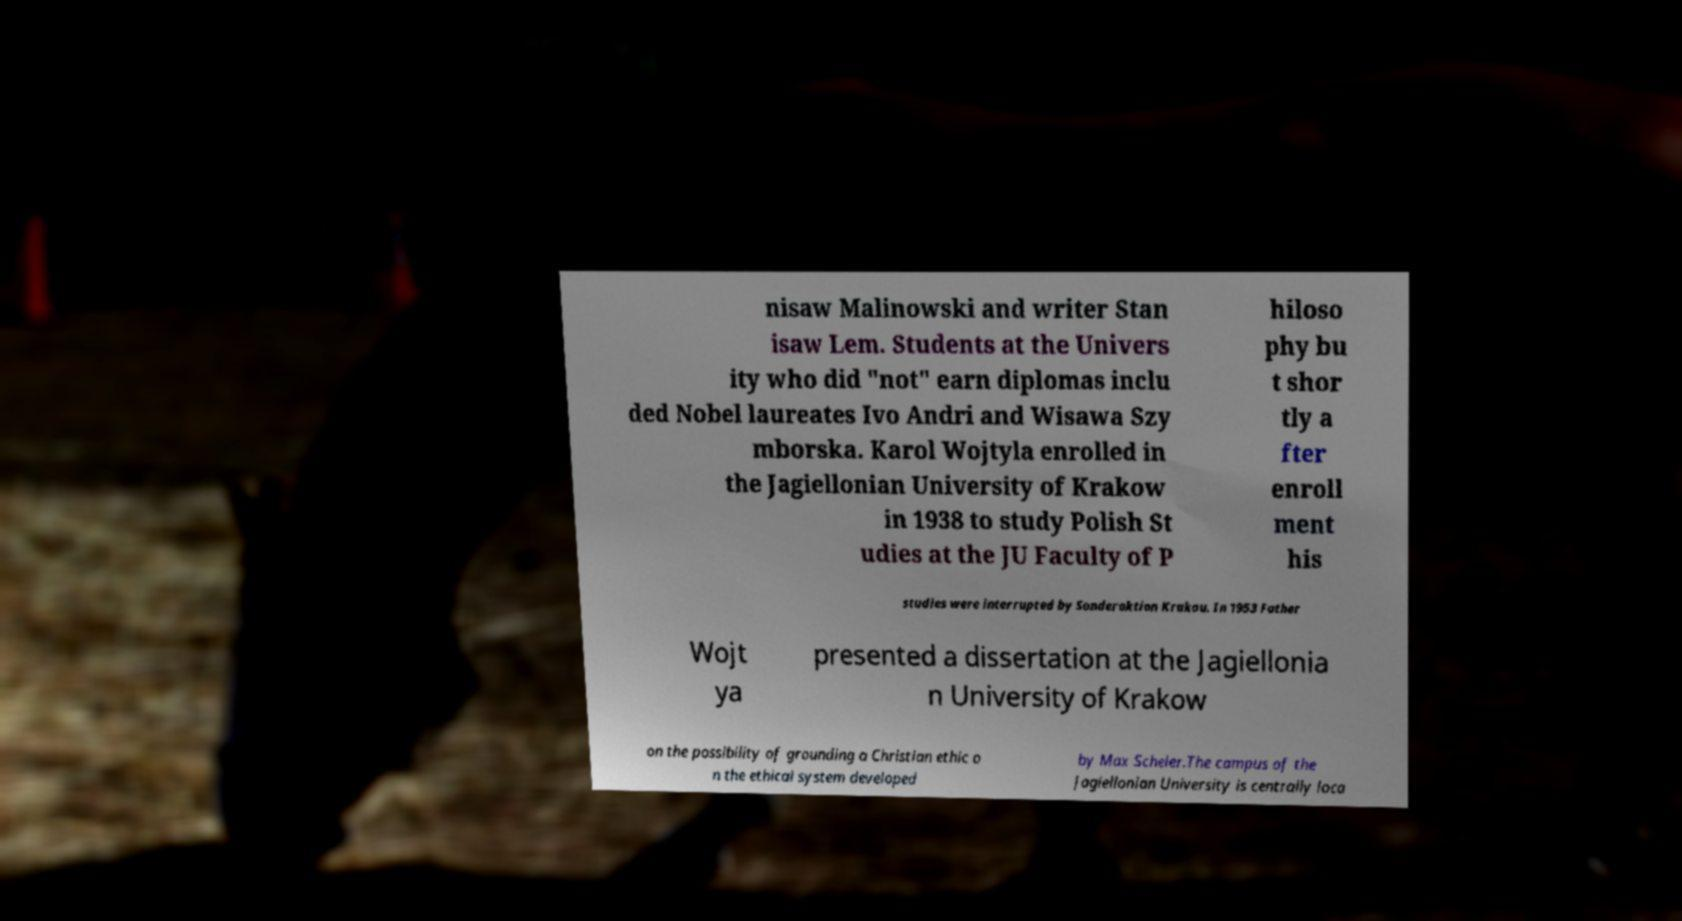Please identify and transcribe the text found in this image. nisaw Malinowski and writer Stan isaw Lem. Students at the Univers ity who did "not" earn diplomas inclu ded Nobel laureates Ivo Andri and Wisawa Szy mborska. Karol Wojtyla enrolled in the Jagiellonian University of Krakow in 1938 to study Polish St udies at the JU Faculty of P hiloso phy bu t shor tly a fter enroll ment his studies were interrupted by Sonderaktion Krakau. In 1953 Father Wojt ya presented a dissertation at the Jagiellonia n University of Krakow on the possibility of grounding a Christian ethic o n the ethical system developed by Max Scheler.The campus of the Jagiellonian University is centrally loca 